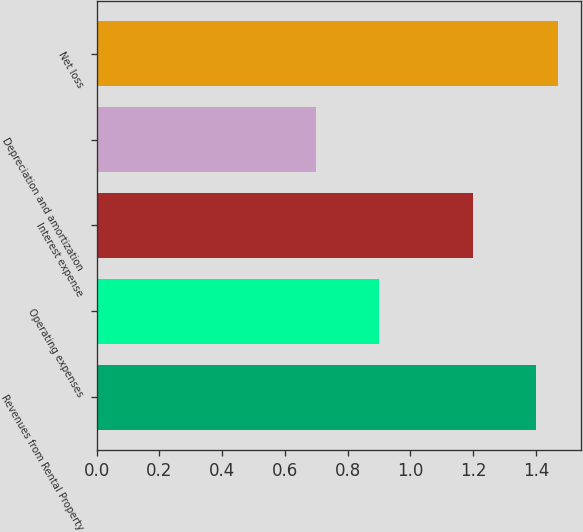<chart> <loc_0><loc_0><loc_500><loc_500><bar_chart><fcel>Revenues from Rental Property<fcel>Operating expenses<fcel>Interest expense<fcel>Depreciation and amortization<fcel>Net loss<nl><fcel>1.4<fcel>0.9<fcel>1.2<fcel>0.7<fcel>1.47<nl></chart> 